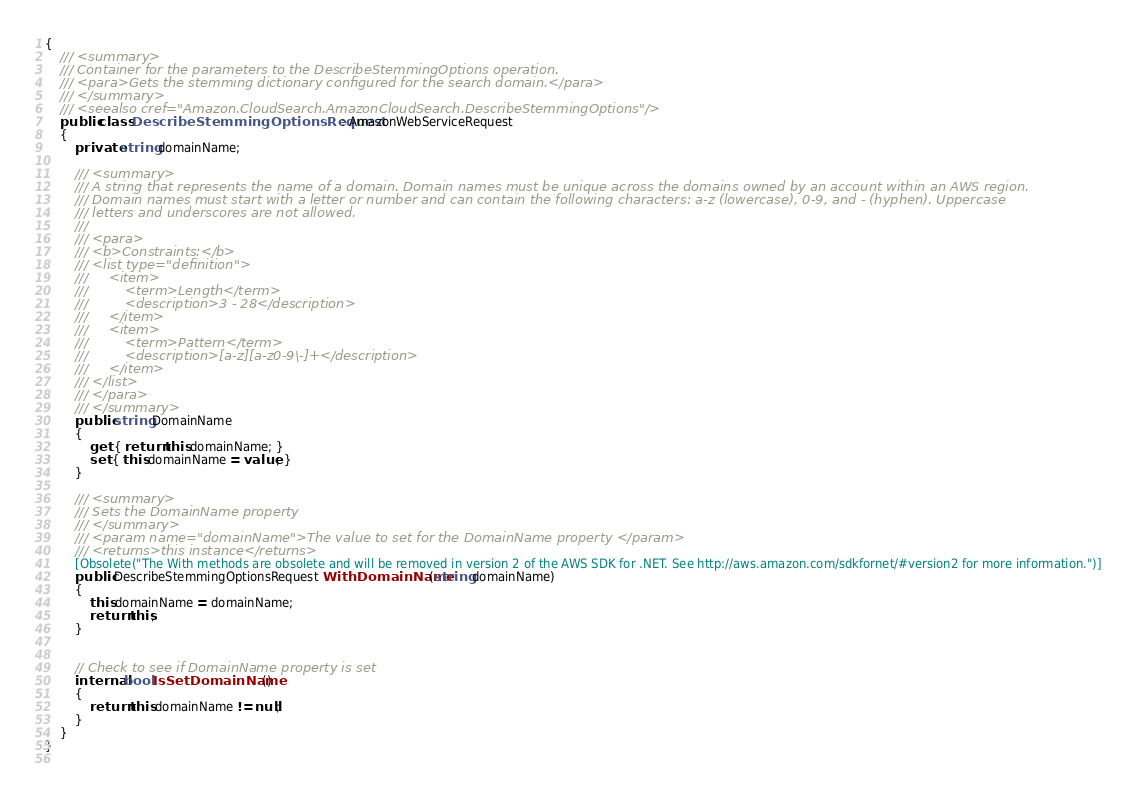<code> <loc_0><loc_0><loc_500><loc_500><_C#_>{
    /// <summary>
    /// Container for the parameters to the DescribeStemmingOptions operation.
    /// <para>Gets the stemming dictionary configured for the search domain.</para>
    /// </summary>
    /// <seealso cref="Amazon.CloudSearch.AmazonCloudSearch.DescribeStemmingOptions"/>
    public class DescribeStemmingOptionsRequest : AmazonWebServiceRequest
    {
        private string domainName;

        /// <summary>
        /// A string that represents the name of a domain. Domain names must be unique across the domains owned by an account within an AWS region.
        /// Domain names must start with a letter or number and can contain the following characters: a-z (lowercase), 0-9, and - (hyphen). Uppercase
        /// letters and underscores are not allowed.
        ///  
        /// <para>
        /// <b>Constraints:</b>
        /// <list type="definition">
        ///     <item>
        ///         <term>Length</term>
        ///         <description>3 - 28</description>
        ///     </item>
        ///     <item>
        ///         <term>Pattern</term>
        ///         <description>[a-z][a-z0-9\-]+</description>
        ///     </item>
        /// </list>
        /// </para>
        /// </summary>
        public string DomainName
        {
            get { return this.domainName; }
            set { this.domainName = value; }
        }

        /// <summary>
        /// Sets the DomainName property
        /// </summary>
        /// <param name="domainName">The value to set for the DomainName property </param>
        /// <returns>this instance</returns>
        [Obsolete("The With methods are obsolete and will be removed in version 2 of the AWS SDK for .NET. See http://aws.amazon.com/sdkfornet/#version2 for more information.")]
        public DescribeStemmingOptionsRequest WithDomainName(string domainName)
        {
            this.domainName = domainName;
            return this;
        }
            

        // Check to see if DomainName property is set
        internal bool IsSetDomainName()
        {
            return this.domainName != null;
        }
    }
}
    
</code> 